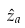<formula> <loc_0><loc_0><loc_500><loc_500>\hat { z } _ { a }</formula> 